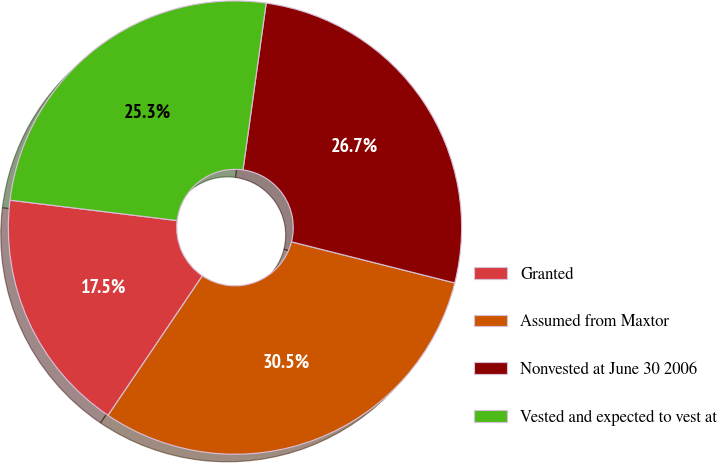<chart> <loc_0><loc_0><loc_500><loc_500><pie_chart><fcel>Granted<fcel>Assumed from Maxtor<fcel>Nonvested at June 30 2006<fcel>Vested and expected to vest at<nl><fcel>17.47%<fcel>30.53%<fcel>26.73%<fcel>25.27%<nl></chart> 